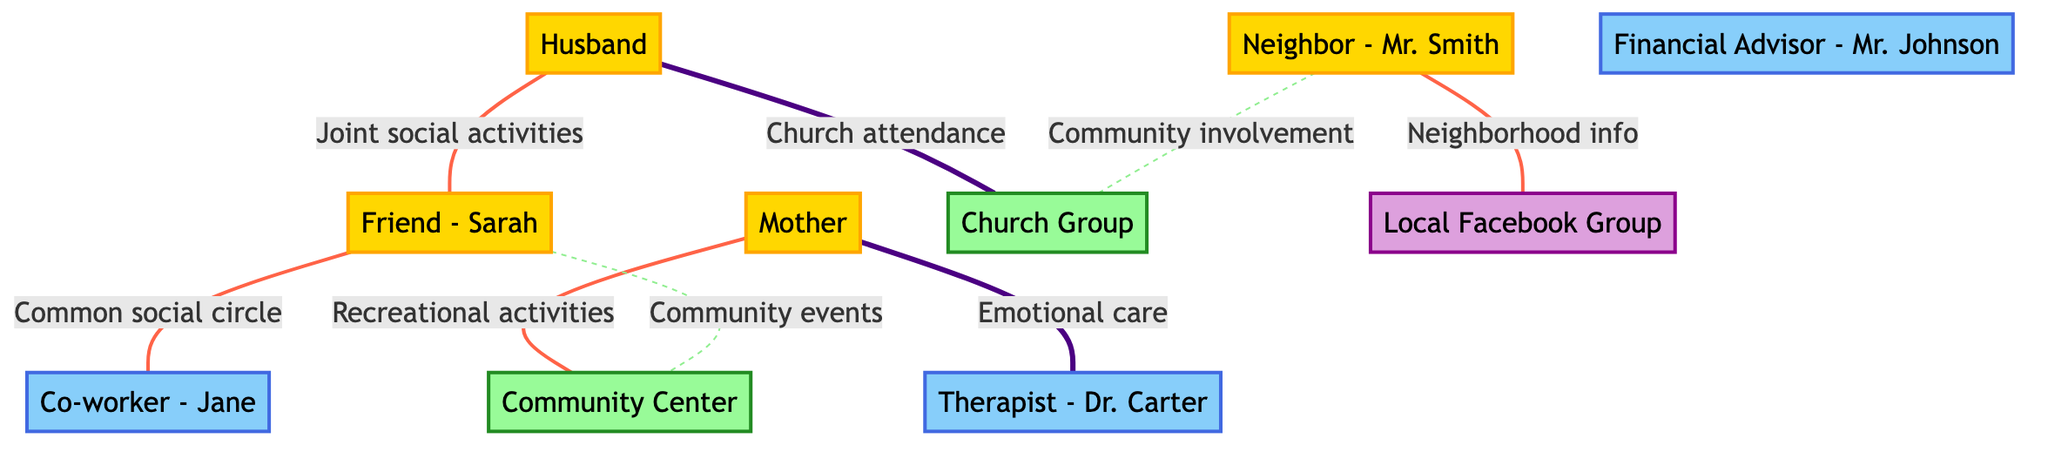What is the emotional support source from the mother? The diagram indicates that the relationship between the "Mother" (node 2) and the "Therapist - Dr. Carter" (node 8) is labeled as "Emotional care," which represents the emotional support provided by the mother.
Answer: Therapist - Dr. Carter Which two nodes are connected by the strongest edge? To determine the strongest edge, I reviewed each edge's strength in the diagram. The connection from "Husband" (node 1) to "Church Group" (node 7) is noted as having a "high" strength. Therefore, these two nodes have the strongest edge.
Answer: Husband and Church Group How many nodes are connected to the Community Center? I looked at the "Community Center" (node 6) in the diagram. The edges connected to it are from "Mother" (node 2) and "Friend - Sarah" (node 3). Thus, there are two nodes connected to the Community Center.
Answer: 2 What type of support does the neighbor provide? The "Neighbor - Mr. Smith" (node 5) has connections to "Church Group" (node 7) and "Local Facebook Group" (node 10), but the connections do not specify the type of support. However, the descriptions indicate he provides helpful assistance for day-to-day needs, including minor home repairs.
Answer: Day-to-day needs What is the relationship strength between the Husband and Friend? The edge connecting "Husband" (node 1) and "Friend - Sarah" (node 3) is labeled as "Joint social activities" with a "medium" strength. This detail signifies the level of interaction and support between these two nodes.
Answer: Medium 